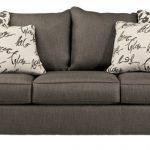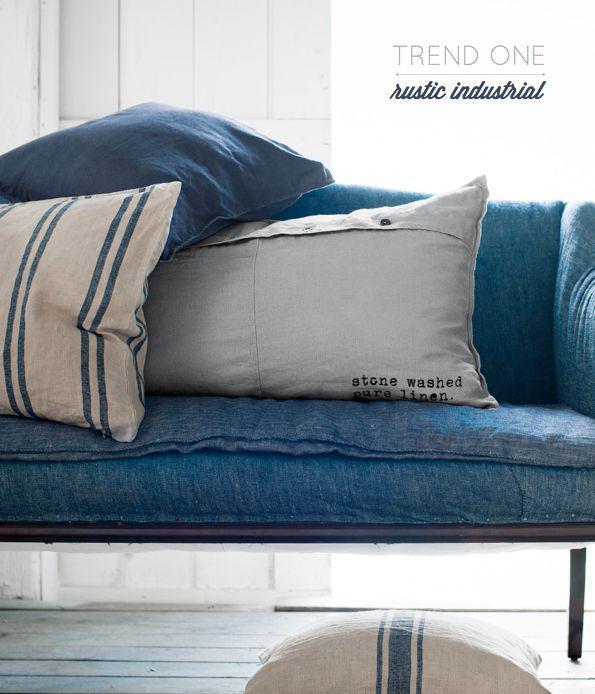The first image is the image on the left, the second image is the image on the right. Analyze the images presented: Is the assertion "A solid color loveseat on short legs with two throw pillows is in one image, with the other image showing a wide black tufted floor lounger with two matching pillows." valid? Answer yes or no. No. The first image is the image on the left, the second image is the image on the right. Analyze the images presented: Is the assertion "A tufted black cushion sits like a chair without legs and has two black throw pillows on it." valid? Answer yes or no. No. 